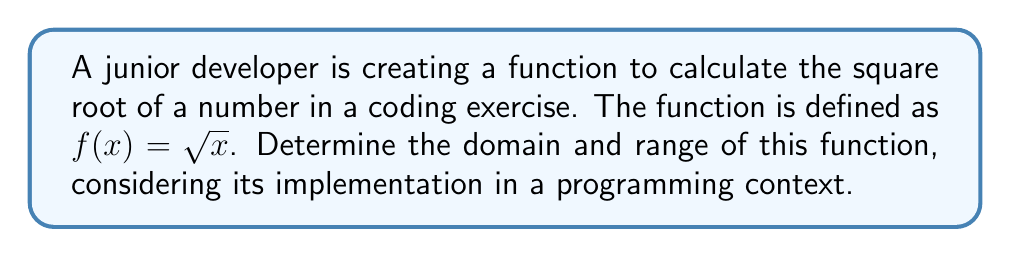Give your solution to this math problem. Let's approach this step-by-step:

1) Domain:
   In mathematics, the domain of $f(x) = \sqrt{x}$ is all non-negative real numbers.
   In programming, we need to consider the limitations of floating-point arithmetic:
   - The minimum positive value that can be represented is typically around $2^{-1022}$ for double precision.
   - The maximum value is around $2^{1023}$ for double precision.

   Therefore, the domain in a programming context is:
   $$ x \in [2^{-1022}, 2^{1023}] $$

2) Range:
   The range of $\sqrt{x}$ is all non-negative real numbers in mathematics.
   In programming, the range is limited by the precision of floating-point numbers:
   - The minimum value is $\sqrt{2^{-1022}} \approx 2^{-511}$
   - The maximum value is $\sqrt{2^{1023}} \approx 2^{511.5}$

   Therefore, the range in a programming context is:
   $$ y \in [2^{-511}, 2^{511.5}] $$

3) Considerations for implementation:
   - Input validation should be implemented to ensure x is non-negative.
   - Error handling should be added for cases where x is outside the valid domain.
   - The developer should be aware of potential loss of precision for very small or very large inputs.
Answer: Domain: $[2^{-1022}, 2^{1023}]$, Range: $[2^{-511}, 2^{511.5}]$ 